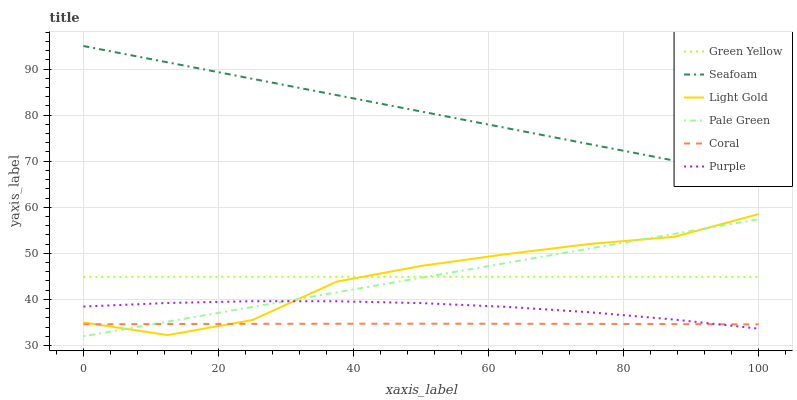Does Coral have the minimum area under the curve?
Answer yes or no. Yes. Does Seafoam have the maximum area under the curve?
Answer yes or no. Yes. Does Seafoam have the minimum area under the curve?
Answer yes or no. No. Does Coral have the maximum area under the curve?
Answer yes or no. No. Is Seafoam the smoothest?
Answer yes or no. Yes. Is Light Gold the roughest?
Answer yes or no. Yes. Is Coral the smoothest?
Answer yes or no. No. Is Coral the roughest?
Answer yes or no. No. Does Coral have the lowest value?
Answer yes or no. No. Does Seafoam have the highest value?
Answer yes or no. Yes. Does Coral have the highest value?
Answer yes or no. No. Is Green Yellow less than Seafoam?
Answer yes or no. Yes. Is Green Yellow greater than Purple?
Answer yes or no. Yes. Does Green Yellow intersect Seafoam?
Answer yes or no. No. 